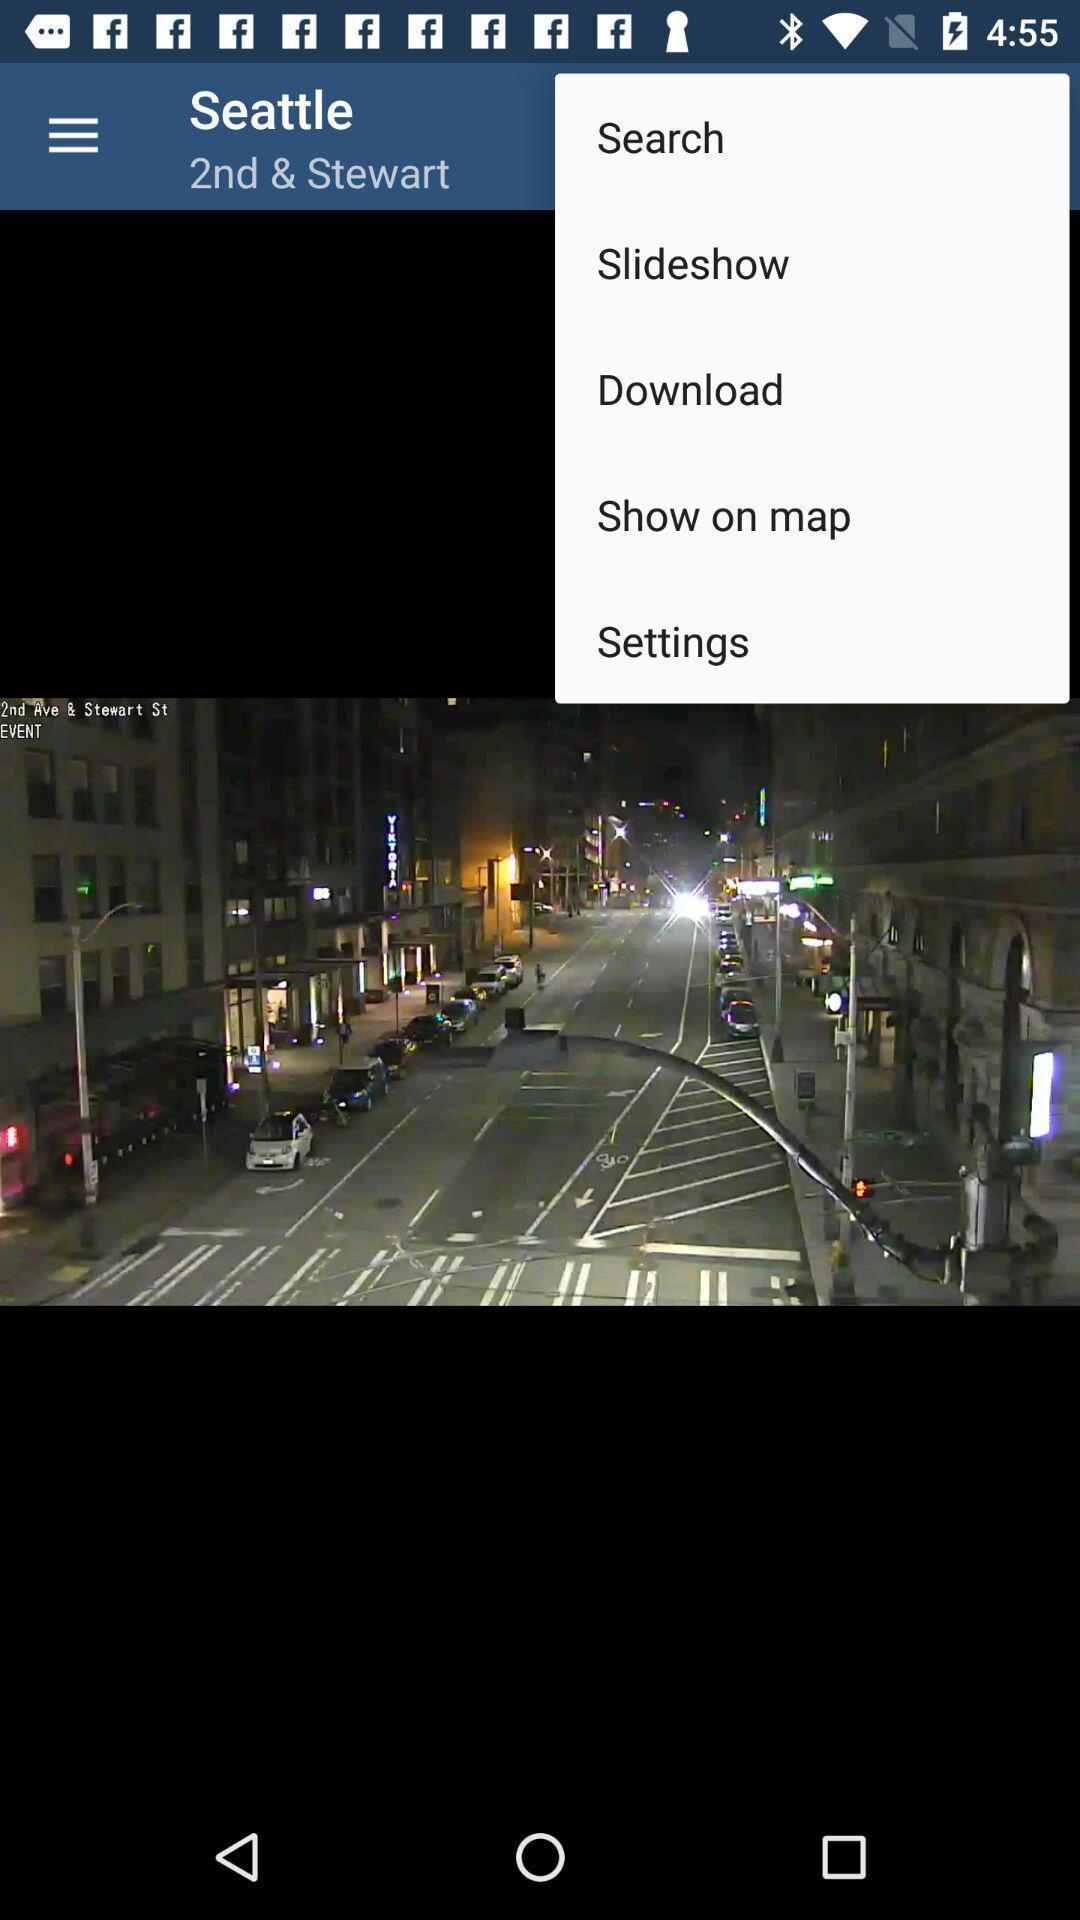Describe the key features of this screenshot. Screen shows image with multiple options. 